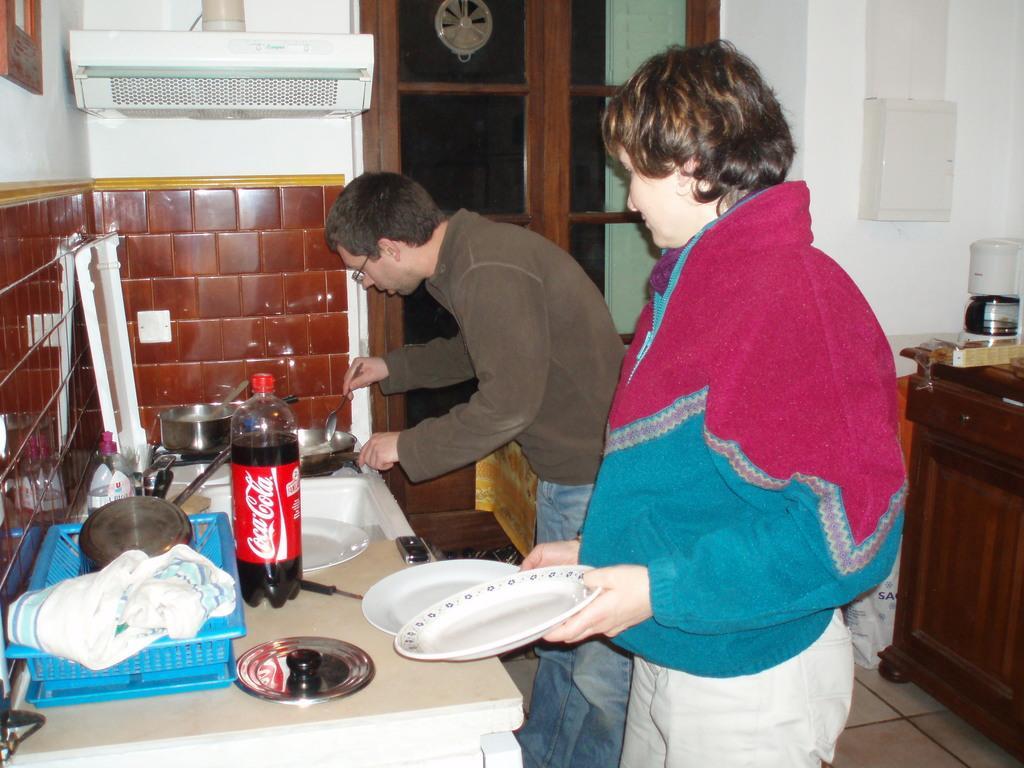Describe this image in one or two sentences. In this image there is a woman holding the plates. Beside her there is a person holding the pan and a spoon. In front of them there is a table. On top of it there is a coca cola bottle and a few other objects. Behind them there is a wooden table. On top of it there is some object. In the center of the image there is a glass door. There is a towel. In the background of the image there is a wall. On the left side of the image there is a chimney and there is a photo frame on the wall. 